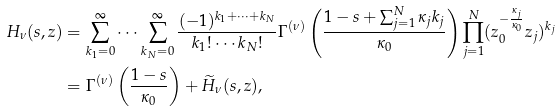<formula> <loc_0><loc_0><loc_500><loc_500>H _ { \nu } ( s , z ) & = \sum _ { k _ { 1 } = 0 } ^ { \infty } \cdots \sum _ { k _ { N } = 0 } ^ { \infty } \frac { ( - 1 ) ^ { k _ { 1 } + \cdots + k _ { N } } } { k _ { 1 } ! \cdots k _ { N } ! } \Gamma ^ { ( \nu ) } \left ( \frac { 1 - s + \sum _ { j = 1 } ^ { N } \kappa _ { j } k _ { j } } { \kappa _ { 0 } } \right ) \prod _ { j = 1 } ^ { N } ( z _ { 0 } ^ { - \frac { \kappa _ { j } } { \kappa _ { 0 } } } z _ { j } ) ^ { k _ { j } } \\ & = \Gamma ^ { ( \nu ) } \left ( \frac { 1 - s } { \kappa _ { 0 } } \right ) + \widetilde { H } _ { \nu } ( s , z ) ,</formula> 